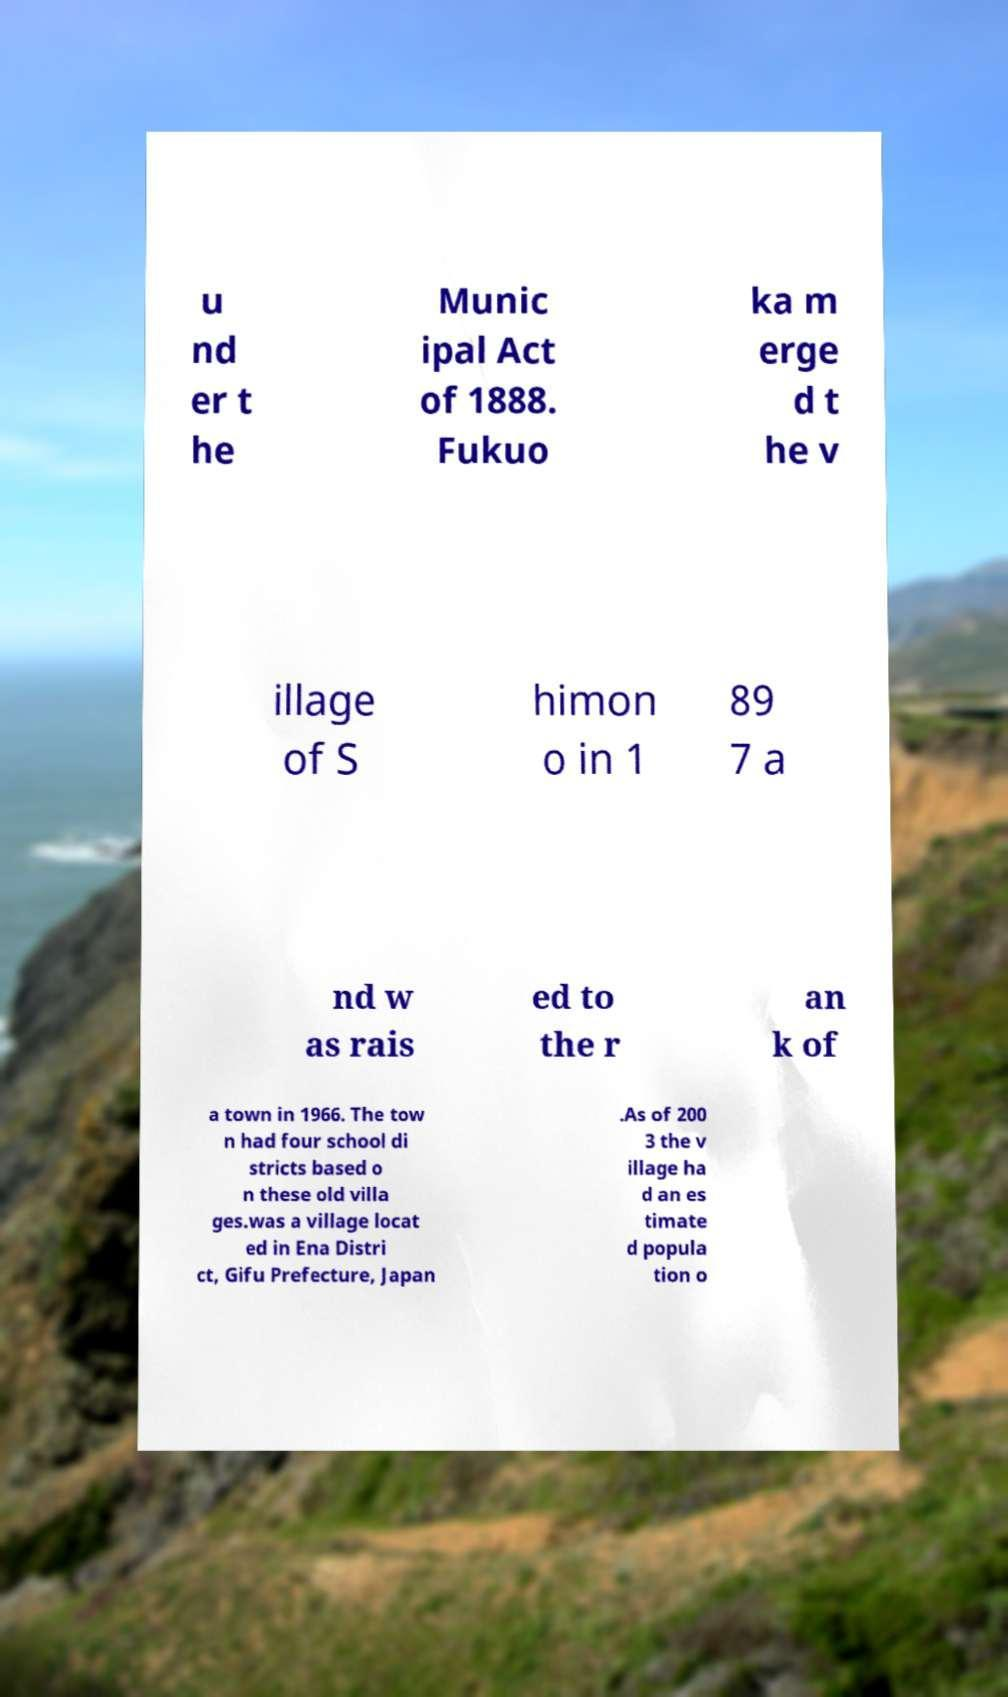For documentation purposes, I need the text within this image transcribed. Could you provide that? u nd er t he Munic ipal Act of 1888. Fukuo ka m erge d t he v illage of S himon o in 1 89 7 a nd w as rais ed to the r an k of a town in 1966. The tow n had four school di stricts based o n these old villa ges.was a village locat ed in Ena Distri ct, Gifu Prefecture, Japan .As of 200 3 the v illage ha d an es timate d popula tion o 